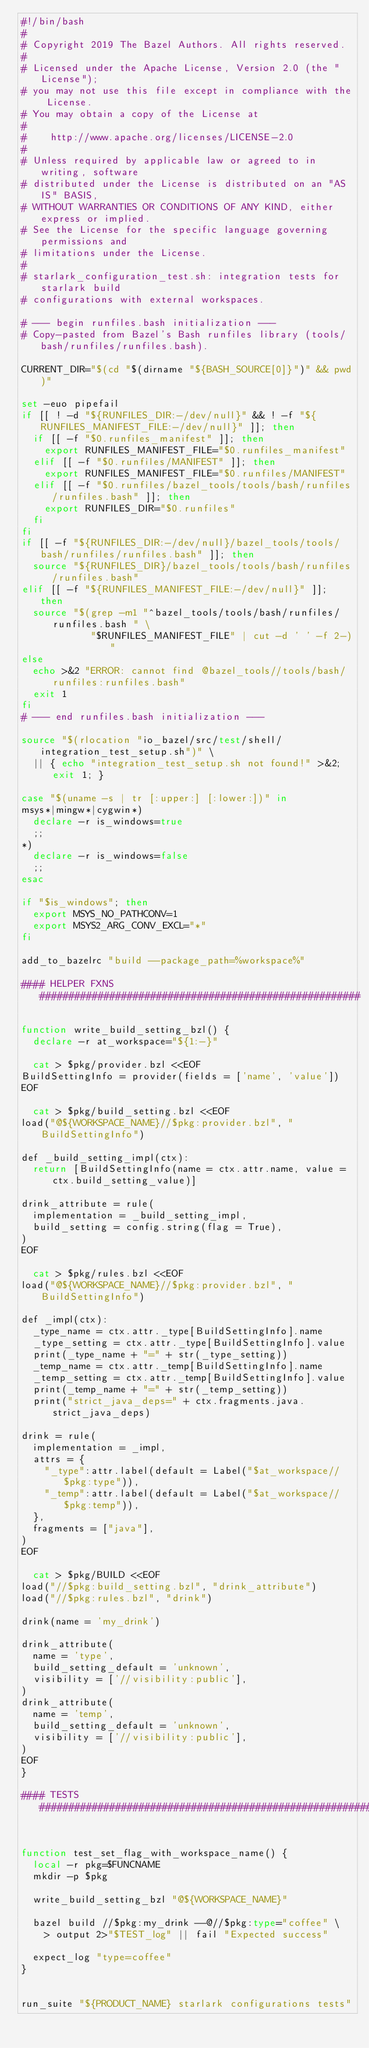<code> <loc_0><loc_0><loc_500><loc_500><_Bash_>#!/bin/bash
#
# Copyright 2019 The Bazel Authors. All rights reserved.
#
# Licensed under the Apache License, Version 2.0 (the "License");
# you may not use this file except in compliance with the License.
# You may obtain a copy of the License at
#
#    http://www.apache.org/licenses/LICENSE-2.0
#
# Unless required by applicable law or agreed to in writing, software
# distributed under the License is distributed on an "AS IS" BASIS,
# WITHOUT WARRANTIES OR CONDITIONS OF ANY KIND, either express or implied.
# See the License for the specific language governing permissions and
# limitations under the License.
#
# starlark_configuration_test.sh: integration tests for starlark build
# configurations with external workspaces.

# --- begin runfiles.bash initialization ---
# Copy-pasted from Bazel's Bash runfiles library (tools/bash/runfiles/runfiles.bash).

CURRENT_DIR="$(cd "$(dirname "${BASH_SOURCE[0]}")" && pwd)"

set -euo pipefail
if [[ ! -d "${RUNFILES_DIR:-/dev/null}" && ! -f "${RUNFILES_MANIFEST_FILE:-/dev/null}" ]]; then
  if [[ -f "$0.runfiles_manifest" ]]; then
    export RUNFILES_MANIFEST_FILE="$0.runfiles_manifest"
  elif [[ -f "$0.runfiles/MANIFEST" ]]; then
    export RUNFILES_MANIFEST_FILE="$0.runfiles/MANIFEST"
  elif [[ -f "$0.runfiles/bazel_tools/tools/bash/runfiles/runfiles.bash" ]]; then
    export RUNFILES_DIR="$0.runfiles"
  fi
fi
if [[ -f "${RUNFILES_DIR:-/dev/null}/bazel_tools/tools/bash/runfiles/runfiles.bash" ]]; then
  source "${RUNFILES_DIR}/bazel_tools/tools/bash/runfiles/runfiles.bash"
elif [[ -f "${RUNFILES_MANIFEST_FILE:-/dev/null}" ]]; then
  source "$(grep -m1 "^bazel_tools/tools/bash/runfiles/runfiles.bash " \
            "$RUNFILES_MANIFEST_FILE" | cut -d ' ' -f 2-)"
else
  echo >&2 "ERROR: cannot find @bazel_tools//tools/bash/runfiles:runfiles.bash"
  exit 1
fi
# --- end runfiles.bash initialization ---

source "$(rlocation "io_bazel/src/test/shell/integration_test_setup.sh")" \
  || { echo "integration_test_setup.sh not found!" >&2; exit 1; }

case "$(uname -s | tr [:upper:] [:lower:])" in
msys*|mingw*|cygwin*)
  declare -r is_windows=true
  ;;
*)
  declare -r is_windows=false
  ;;
esac

if "$is_windows"; then
  export MSYS_NO_PATHCONV=1
  export MSYS2_ARG_CONV_EXCL="*"
fi

add_to_bazelrc "build --package_path=%workspace%"

#### HELPER FXNS #######################################################

function write_build_setting_bzl() {
  declare -r at_workspace="${1:-}"

  cat > $pkg/provider.bzl <<EOF
BuildSettingInfo = provider(fields = ['name', 'value'])
EOF

  cat > $pkg/build_setting.bzl <<EOF
load("@${WORKSPACE_NAME}//$pkg:provider.bzl", "BuildSettingInfo")

def _build_setting_impl(ctx):
  return [BuildSettingInfo(name = ctx.attr.name, value = ctx.build_setting_value)]

drink_attribute = rule(
  implementation = _build_setting_impl,
  build_setting = config.string(flag = True),
)
EOF

  cat > $pkg/rules.bzl <<EOF
load("@${WORKSPACE_NAME}//$pkg:provider.bzl", "BuildSettingInfo")

def _impl(ctx):
  _type_name = ctx.attr._type[BuildSettingInfo].name
  _type_setting = ctx.attr._type[BuildSettingInfo].value
  print(_type_name + "=" + str(_type_setting))
  _temp_name = ctx.attr._temp[BuildSettingInfo].name
  _temp_setting = ctx.attr._temp[BuildSettingInfo].value
  print(_temp_name + "=" + str(_temp_setting))
  print("strict_java_deps=" + ctx.fragments.java.strict_java_deps)

drink = rule(
  implementation = _impl,
  attrs = {
    "_type":attr.label(default = Label("$at_workspace//$pkg:type")),
    "_temp":attr.label(default = Label("$at_workspace//$pkg:temp")),
  },
  fragments = ["java"],
)
EOF

  cat > $pkg/BUILD <<EOF
load("//$pkg:build_setting.bzl", "drink_attribute")
load("//$pkg:rules.bzl", "drink")

drink(name = 'my_drink')

drink_attribute(
  name = 'type',
  build_setting_default = 'unknown',
  visibility = ['//visibility:public'],
)
drink_attribute(
  name = 'temp',
  build_setting_default = 'unknown',
  visibility = ['//visibility:public'],
)
EOF
}

#### TESTS #############################################################


function test_set_flag_with_workspace_name() {
  local -r pkg=$FUNCNAME
  mkdir -p $pkg

  write_build_setting_bzl "@${WORKSPACE_NAME}"

  bazel build //$pkg:my_drink --@//$pkg:type="coffee" \
    > output 2>"$TEST_log" || fail "Expected success"

  expect_log "type=coffee"
}


run_suite "${PRODUCT_NAME} starlark configurations tests"
</code> 